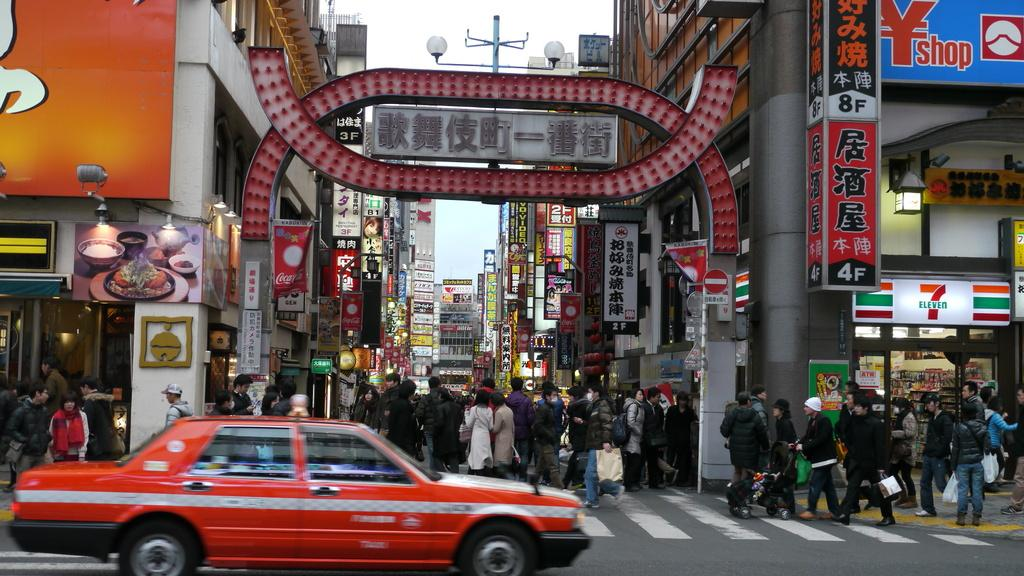<image>
Present a compact description of the photo's key features. A crowded street in front of a 7 Eleven and some Coca Cola banners. 